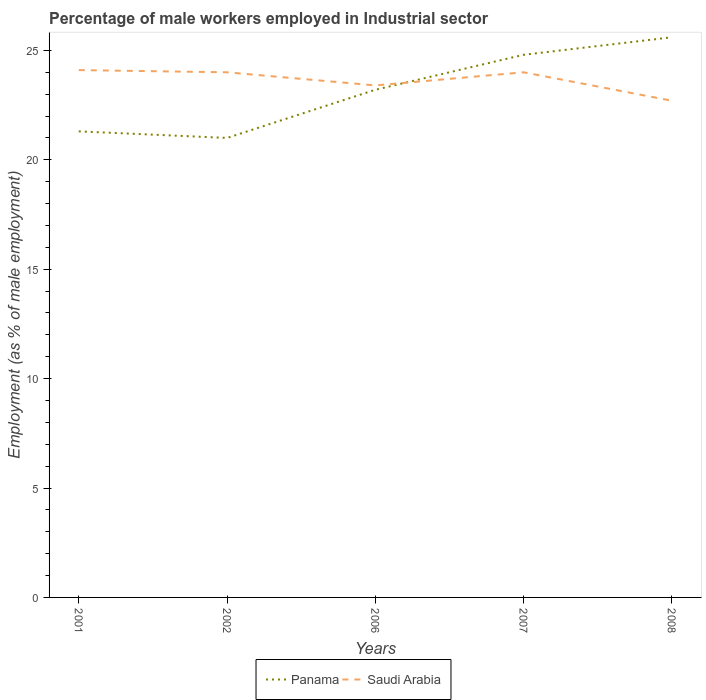How many different coloured lines are there?
Provide a short and direct response. 2. Is the number of lines equal to the number of legend labels?
Make the answer very short. Yes. What is the total percentage of male workers employed in Industrial sector in Saudi Arabia in the graph?
Ensure brevity in your answer.  0. What is the difference between the highest and the second highest percentage of male workers employed in Industrial sector in Panama?
Provide a succinct answer. 4.6. What is the difference between the highest and the lowest percentage of male workers employed in Industrial sector in Panama?
Provide a short and direct response. 3. How many lines are there?
Provide a succinct answer. 2. How many years are there in the graph?
Your answer should be compact. 5. Does the graph contain any zero values?
Keep it short and to the point. No. Does the graph contain grids?
Your answer should be very brief. No. Where does the legend appear in the graph?
Keep it short and to the point. Bottom center. What is the title of the graph?
Your response must be concise. Percentage of male workers employed in Industrial sector. What is the label or title of the Y-axis?
Offer a terse response. Employment (as % of male employment). What is the Employment (as % of male employment) in Panama in 2001?
Keep it short and to the point. 21.3. What is the Employment (as % of male employment) in Saudi Arabia in 2001?
Offer a very short reply. 24.1. What is the Employment (as % of male employment) in Saudi Arabia in 2002?
Give a very brief answer. 24. What is the Employment (as % of male employment) in Panama in 2006?
Your answer should be very brief. 23.2. What is the Employment (as % of male employment) of Saudi Arabia in 2006?
Ensure brevity in your answer.  23.4. What is the Employment (as % of male employment) in Panama in 2007?
Give a very brief answer. 24.8. What is the Employment (as % of male employment) of Panama in 2008?
Your response must be concise. 25.6. What is the Employment (as % of male employment) of Saudi Arabia in 2008?
Offer a very short reply. 22.7. Across all years, what is the maximum Employment (as % of male employment) in Panama?
Make the answer very short. 25.6. Across all years, what is the maximum Employment (as % of male employment) in Saudi Arabia?
Make the answer very short. 24.1. Across all years, what is the minimum Employment (as % of male employment) in Panama?
Your response must be concise. 21. Across all years, what is the minimum Employment (as % of male employment) in Saudi Arabia?
Offer a terse response. 22.7. What is the total Employment (as % of male employment) of Panama in the graph?
Keep it short and to the point. 115.9. What is the total Employment (as % of male employment) of Saudi Arabia in the graph?
Provide a succinct answer. 118.2. What is the difference between the Employment (as % of male employment) in Saudi Arabia in 2001 and that in 2002?
Your response must be concise. 0.1. What is the difference between the Employment (as % of male employment) of Saudi Arabia in 2001 and that in 2006?
Provide a short and direct response. 0.7. What is the difference between the Employment (as % of male employment) in Panama in 2001 and that in 2008?
Provide a succinct answer. -4.3. What is the difference between the Employment (as % of male employment) in Saudi Arabia in 2001 and that in 2008?
Make the answer very short. 1.4. What is the difference between the Employment (as % of male employment) of Saudi Arabia in 2002 and that in 2007?
Ensure brevity in your answer.  0. What is the difference between the Employment (as % of male employment) in Panama in 2002 and that in 2008?
Make the answer very short. -4.6. What is the difference between the Employment (as % of male employment) in Saudi Arabia in 2002 and that in 2008?
Ensure brevity in your answer.  1.3. What is the difference between the Employment (as % of male employment) of Panama in 2006 and that in 2007?
Offer a terse response. -1.6. What is the difference between the Employment (as % of male employment) in Panama in 2006 and that in 2008?
Offer a terse response. -2.4. What is the difference between the Employment (as % of male employment) of Saudi Arabia in 2007 and that in 2008?
Offer a terse response. 1.3. What is the difference between the Employment (as % of male employment) of Panama in 2001 and the Employment (as % of male employment) of Saudi Arabia in 2006?
Offer a terse response. -2.1. What is the difference between the Employment (as % of male employment) in Panama in 2001 and the Employment (as % of male employment) in Saudi Arabia in 2008?
Your response must be concise. -1.4. What is the difference between the Employment (as % of male employment) of Panama in 2002 and the Employment (as % of male employment) of Saudi Arabia in 2007?
Offer a very short reply. -3. What is the difference between the Employment (as % of male employment) of Panama in 2006 and the Employment (as % of male employment) of Saudi Arabia in 2007?
Your answer should be very brief. -0.8. What is the difference between the Employment (as % of male employment) in Panama in 2006 and the Employment (as % of male employment) in Saudi Arabia in 2008?
Offer a very short reply. 0.5. What is the difference between the Employment (as % of male employment) in Panama in 2007 and the Employment (as % of male employment) in Saudi Arabia in 2008?
Provide a succinct answer. 2.1. What is the average Employment (as % of male employment) of Panama per year?
Your response must be concise. 23.18. What is the average Employment (as % of male employment) of Saudi Arabia per year?
Give a very brief answer. 23.64. In the year 2006, what is the difference between the Employment (as % of male employment) in Panama and Employment (as % of male employment) in Saudi Arabia?
Ensure brevity in your answer.  -0.2. In the year 2007, what is the difference between the Employment (as % of male employment) of Panama and Employment (as % of male employment) of Saudi Arabia?
Your response must be concise. 0.8. In the year 2008, what is the difference between the Employment (as % of male employment) in Panama and Employment (as % of male employment) in Saudi Arabia?
Your answer should be very brief. 2.9. What is the ratio of the Employment (as % of male employment) of Panama in 2001 to that in 2002?
Your response must be concise. 1.01. What is the ratio of the Employment (as % of male employment) of Panama in 2001 to that in 2006?
Your answer should be very brief. 0.92. What is the ratio of the Employment (as % of male employment) in Saudi Arabia in 2001 to that in 2006?
Provide a short and direct response. 1.03. What is the ratio of the Employment (as % of male employment) of Panama in 2001 to that in 2007?
Provide a succinct answer. 0.86. What is the ratio of the Employment (as % of male employment) of Panama in 2001 to that in 2008?
Provide a short and direct response. 0.83. What is the ratio of the Employment (as % of male employment) in Saudi Arabia in 2001 to that in 2008?
Your answer should be very brief. 1.06. What is the ratio of the Employment (as % of male employment) of Panama in 2002 to that in 2006?
Make the answer very short. 0.91. What is the ratio of the Employment (as % of male employment) in Saudi Arabia in 2002 to that in 2006?
Give a very brief answer. 1.03. What is the ratio of the Employment (as % of male employment) of Panama in 2002 to that in 2007?
Provide a succinct answer. 0.85. What is the ratio of the Employment (as % of male employment) of Panama in 2002 to that in 2008?
Provide a short and direct response. 0.82. What is the ratio of the Employment (as % of male employment) in Saudi Arabia in 2002 to that in 2008?
Keep it short and to the point. 1.06. What is the ratio of the Employment (as % of male employment) in Panama in 2006 to that in 2007?
Make the answer very short. 0.94. What is the ratio of the Employment (as % of male employment) in Saudi Arabia in 2006 to that in 2007?
Give a very brief answer. 0.97. What is the ratio of the Employment (as % of male employment) of Panama in 2006 to that in 2008?
Give a very brief answer. 0.91. What is the ratio of the Employment (as % of male employment) of Saudi Arabia in 2006 to that in 2008?
Offer a terse response. 1.03. What is the ratio of the Employment (as % of male employment) of Panama in 2007 to that in 2008?
Your answer should be compact. 0.97. What is the ratio of the Employment (as % of male employment) in Saudi Arabia in 2007 to that in 2008?
Make the answer very short. 1.06. What is the difference between the highest and the second highest Employment (as % of male employment) in Panama?
Your answer should be very brief. 0.8. What is the difference between the highest and the second highest Employment (as % of male employment) in Saudi Arabia?
Your answer should be compact. 0.1. What is the difference between the highest and the lowest Employment (as % of male employment) in Saudi Arabia?
Your answer should be compact. 1.4. 